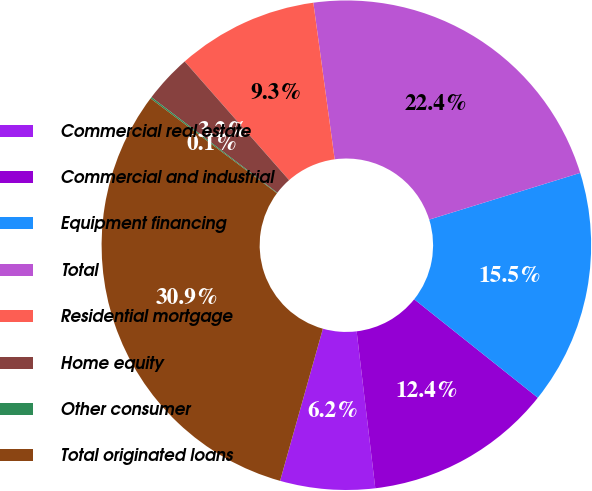Convert chart to OTSL. <chart><loc_0><loc_0><loc_500><loc_500><pie_chart><fcel>Commercial real estate<fcel>Commercial and industrial<fcel>Equipment financing<fcel>Total<fcel>Residential mortgage<fcel>Home equity<fcel>Other consumer<fcel>Total originated loans<nl><fcel>6.25%<fcel>12.41%<fcel>15.48%<fcel>22.38%<fcel>9.33%<fcel>3.18%<fcel>0.1%<fcel>30.87%<nl></chart> 